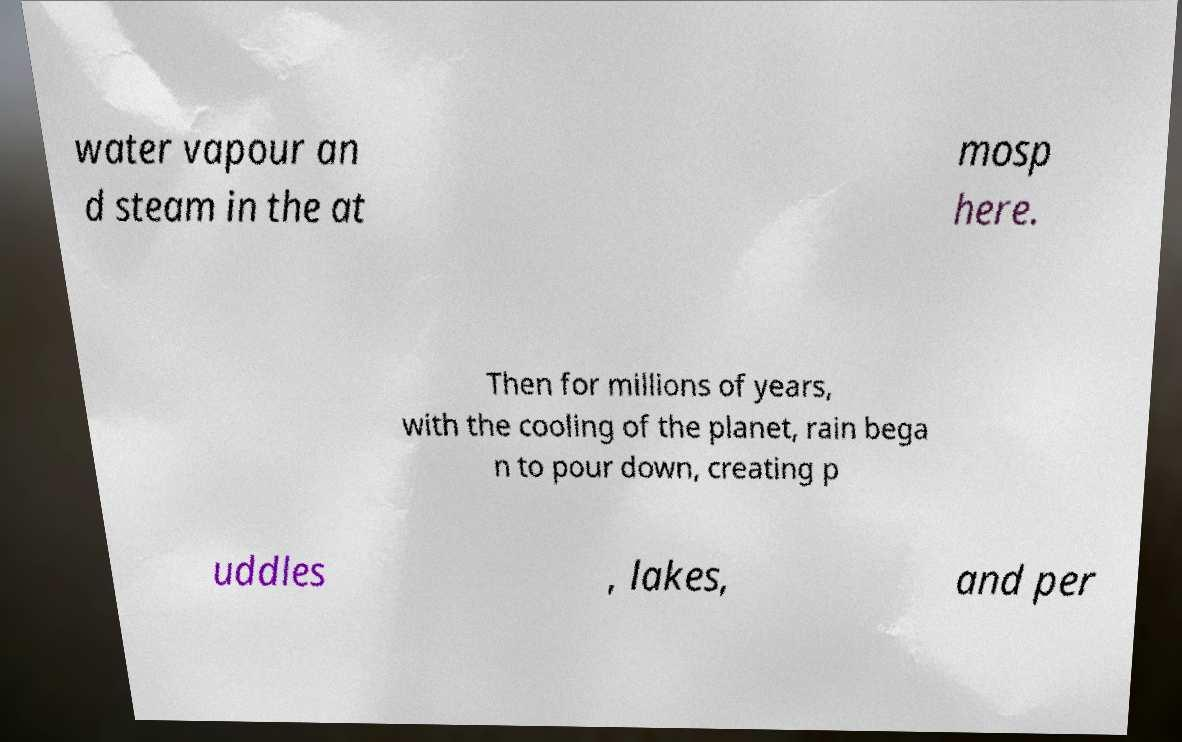Could you extract and type out the text from this image? water vapour an d steam in the at mosp here. Then for millions of years, with the cooling of the planet, rain bega n to pour down, creating p uddles , lakes, and per 